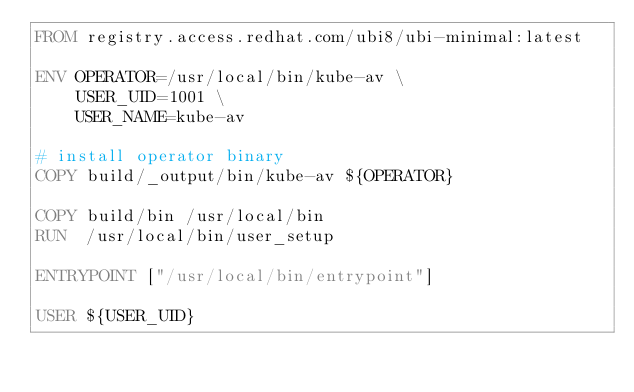Convert code to text. <code><loc_0><loc_0><loc_500><loc_500><_Dockerfile_>FROM registry.access.redhat.com/ubi8/ubi-minimal:latest

ENV OPERATOR=/usr/local/bin/kube-av \
    USER_UID=1001 \
    USER_NAME=kube-av

# install operator binary
COPY build/_output/bin/kube-av ${OPERATOR}

COPY build/bin /usr/local/bin
RUN  /usr/local/bin/user_setup

ENTRYPOINT ["/usr/local/bin/entrypoint"]

USER ${USER_UID}
</code> 